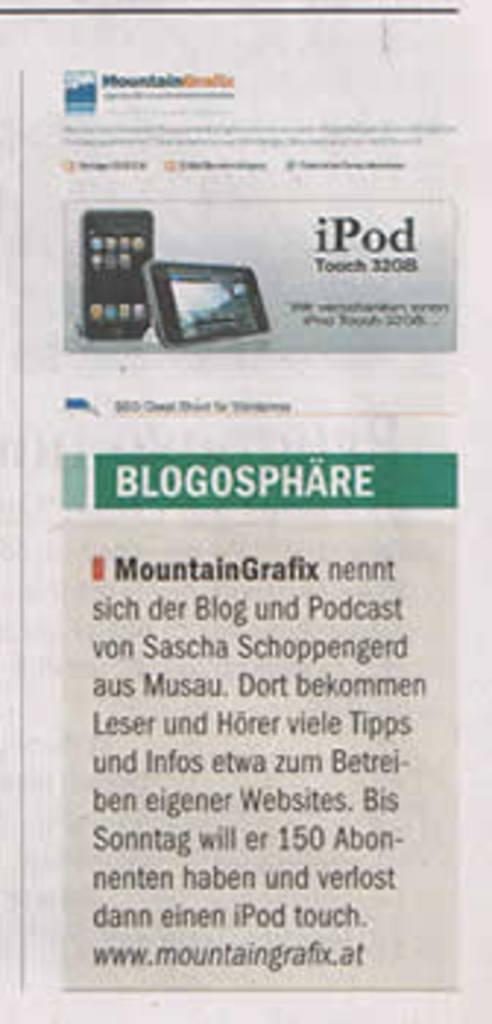<image>
Write a terse but informative summary of the picture. An article features a 32GB iPod above the actual article. 